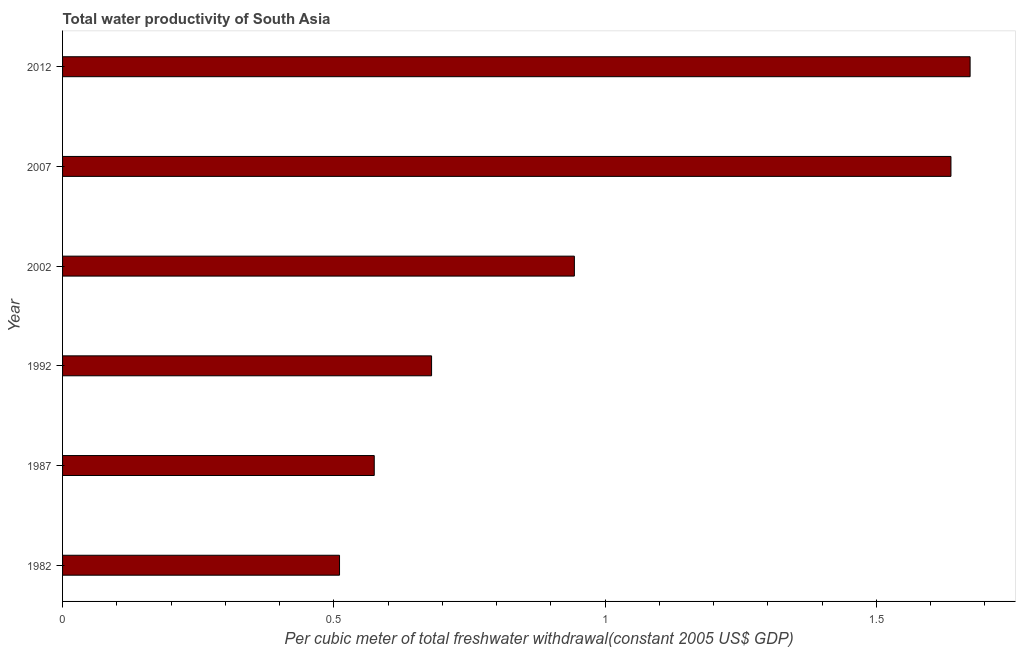Does the graph contain any zero values?
Your answer should be very brief. No. Does the graph contain grids?
Your answer should be very brief. No. What is the title of the graph?
Offer a very short reply. Total water productivity of South Asia. What is the label or title of the X-axis?
Make the answer very short. Per cubic meter of total freshwater withdrawal(constant 2005 US$ GDP). What is the total water productivity in 2002?
Provide a succinct answer. 0.94. Across all years, what is the maximum total water productivity?
Your response must be concise. 1.67. Across all years, what is the minimum total water productivity?
Your answer should be very brief. 0.51. In which year was the total water productivity maximum?
Provide a succinct answer. 2012. What is the sum of the total water productivity?
Offer a very short reply. 6.02. What is the difference between the total water productivity in 2002 and 2007?
Offer a very short reply. -0.69. What is the average total water productivity per year?
Give a very brief answer. 1. What is the median total water productivity?
Give a very brief answer. 0.81. What is the ratio of the total water productivity in 1992 to that in 2012?
Your answer should be compact. 0.41. Is the total water productivity in 1987 less than that in 2007?
Provide a short and direct response. Yes. What is the difference between the highest and the second highest total water productivity?
Give a very brief answer. 0.04. Is the sum of the total water productivity in 2002 and 2012 greater than the maximum total water productivity across all years?
Ensure brevity in your answer.  Yes. What is the difference between the highest and the lowest total water productivity?
Keep it short and to the point. 1.16. In how many years, is the total water productivity greater than the average total water productivity taken over all years?
Provide a succinct answer. 2. Are the values on the major ticks of X-axis written in scientific E-notation?
Give a very brief answer. No. What is the Per cubic meter of total freshwater withdrawal(constant 2005 US$ GDP) of 1982?
Make the answer very short. 0.51. What is the Per cubic meter of total freshwater withdrawal(constant 2005 US$ GDP) in 1987?
Give a very brief answer. 0.57. What is the Per cubic meter of total freshwater withdrawal(constant 2005 US$ GDP) of 1992?
Your answer should be compact. 0.68. What is the Per cubic meter of total freshwater withdrawal(constant 2005 US$ GDP) of 2002?
Provide a succinct answer. 0.94. What is the Per cubic meter of total freshwater withdrawal(constant 2005 US$ GDP) in 2007?
Provide a succinct answer. 1.64. What is the Per cubic meter of total freshwater withdrawal(constant 2005 US$ GDP) in 2012?
Provide a succinct answer. 1.67. What is the difference between the Per cubic meter of total freshwater withdrawal(constant 2005 US$ GDP) in 1982 and 1987?
Keep it short and to the point. -0.06. What is the difference between the Per cubic meter of total freshwater withdrawal(constant 2005 US$ GDP) in 1982 and 1992?
Your answer should be compact. -0.17. What is the difference between the Per cubic meter of total freshwater withdrawal(constant 2005 US$ GDP) in 1982 and 2002?
Give a very brief answer. -0.43. What is the difference between the Per cubic meter of total freshwater withdrawal(constant 2005 US$ GDP) in 1982 and 2007?
Offer a very short reply. -1.13. What is the difference between the Per cubic meter of total freshwater withdrawal(constant 2005 US$ GDP) in 1982 and 2012?
Offer a very short reply. -1.16. What is the difference between the Per cubic meter of total freshwater withdrawal(constant 2005 US$ GDP) in 1987 and 1992?
Make the answer very short. -0.11. What is the difference between the Per cubic meter of total freshwater withdrawal(constant 2005 US$ GDP) in 1987 and 2002?
Your response must be concise. -0.37. What is the difference between the Per cubic meter of total freshwater withdrawal(constant 2005 US$ GDP) in 1987 and 2007?
Provide a succinct answer. -1.06. What is the difference between the Per cubic meter of total freshwater withdrawal(constant 2005 US$ GDP) in 1987 and 2012?
Offer a terse response. -1.1. What is the difference between the Per cubic meter of total freshwater withdrawal(constant 2005 US$ GDP) in 1992 and 2002?
Offer a terse response. -0.26. What is the difference between the Per cubic meter of total freshwater withdrawal(constant 2005 US$ GDP) in 1992 and 2007?
Give a very brief answer. -0.96. What is the difference between the Per cubic meter of total freshwater withdrawal(constant 2005 US$ GDP) in 1992 and 2012?
Give a very brief answer. -0.99. What is the difference between the Per cubic meter of total freshwater withdrawal(constant 2005 US$ GDP) in 2002 and 2007?
Your answer should be very brief. -0.69. What is the difference between the Per cubic meter of total freshwater withdrawal(constant 2005 US$ GDP) in 2002 and 2012?
Keep it short and to the point. -0.73. What is the difference between the Per cubic meter of total freshwater withdrawal(constant 2005 US$ GDP) in 2007 and 2012?
Keep it short and to the point. -0.04. What is the ratio of the Per cubic meter of total freshwater withdrawal(constant 2005 US$ GDP) in 1982 to that in 1987?
Provide a succinct answer. 0.89. What is the ratio of the Per cubic meter of total freshwater withdrawal(constant 2005 US$ GDP) in 1982 to that in 1992?
Your response must be concise. 0.75. What is the ratio of the Per cubic meter of total freshwater withdrawal(constant 2005 US$ GDP) in 1982 to that in 2002?
Provide a succinct answer. 0.54. What is the ratio of the Per cubic meter of total freshwater withdrawal(constant 2005 US$ GDP) in 1982 to that in 2007?
Your answer should be compact. 0.31. What is the ratio of the Per cubic meter of total freshwater withdrawal(constant 2005 US$ GDP) in 1982 to that in 2012?
Offer a terse response. 0.3. What is the ratio of the Per cubic meter of total freshwater withdrawal(constant 2005 US$ GDP) in 1987 to that in 1992?
Your answer should be very brief. 0.84. What is the ratio of the Per cubic meter of total freshwater withdrawal(constant 2005 US$ GDP) in 1987 to that in 2002?
Your answer should be very brief. 0.61. What is the ratio of the Per cubic meter of total freshwater withdrawal(constant 2005 US$ GDP) in 1987 to that in 2007?
Your answer should be very brief. 0.35. What is the ratio of the Per cubic meter of total freshwater withdrawal(constant 2005 US$ GDP) in 1987 to that in 2012?
Provide a succinct answer. 0.34. What is the ratio of the Per cubic meter of total freshwater withdrawal(constant 2005 US$ GDP) in 1992 to that in 2002?
Give a very brief answer. 0.72. What is the ratio of the Per cubic meter of total freshwater withdrawal(constant 2005 US$ GDP) in 1992 to that in 2007?
Ensure brevity in your answer.  0.41. What is the ratio of the Per cubic meter of total freshwater withdrawal(constant 2005 US$ GDP) in 1992 to that in 2012?
Your answer should be compact. 0.41. What is the ratio of the Per cubic meter of total freshwater withdrawal(constant 2005 US$ GDP) in 2002 to that in 2007?
Offer a terse response. 0.58. What is the ratio of the Per cubic meter of total freshwater withdrawal(constant 2005 US$ GDP) in 2002 to that in 2012?
Ensure brevity in your answer.  0.56. 